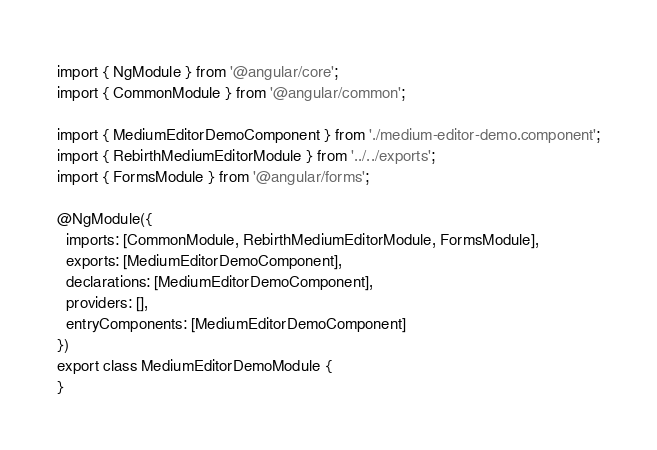<code> <loc_0><loc_0><loc_500><loc_500><_TypeScript_>import { NgModule } from '@angular/core';
import { CommonModule } from '@angular/common';

import { MediumEditorDemoComponent } from './medium-editor-demo.component';
import { RebirthMediumEditorModule } from '../../exports';
import { FormsModule } from '@angular/forms';

@NgModule({
  imports: [CommonModule, RebirthMediumEditorModule, FormsModule],
  exports: [MediumEditorDemoComponent],
  declarations: [MediumEditorDemoComponent],
  providers: [],
  entryComponents: [MediumEditorDemoComponent]
})
export class MediumEditorDemoModule {
}
</code> 